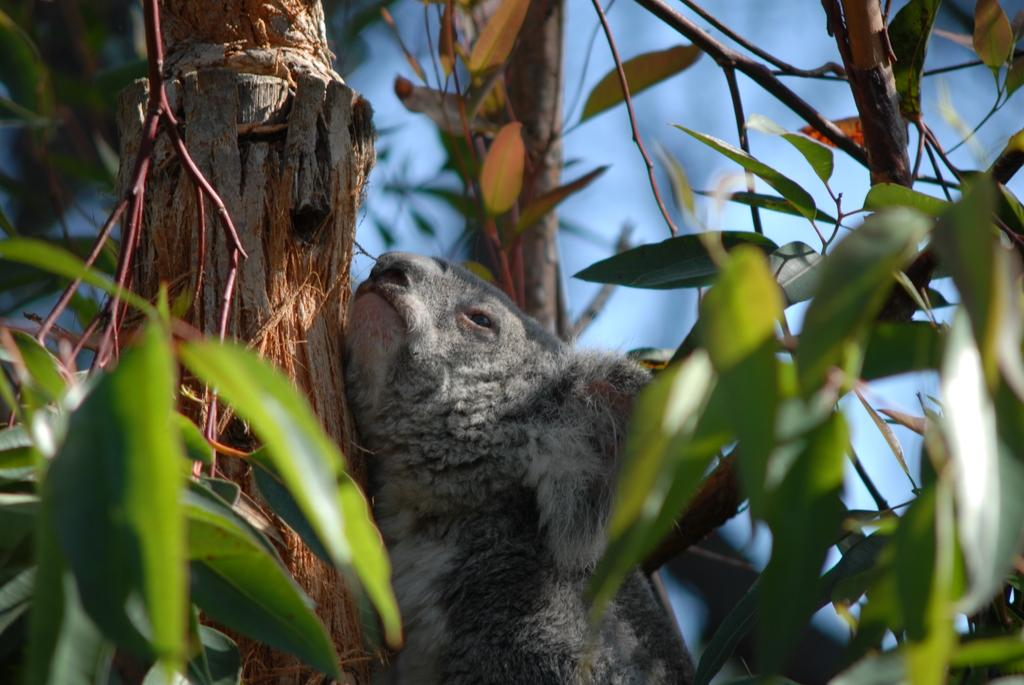What animal is the main subject of the image? There is a koala in the image. Where is the koala located in the image? The koala is on a branch of a tree. What can be seen in the background of the image? There are leaves visible in the background of the image. What type of cannon is being used by the carpenter in the image? There is no cannon or carpenter present in the image; it features a koala on a tree branch. What substance is the koala using to build its nest in the image? The image does not show the koala building a nest or using any substance for that purpose. 